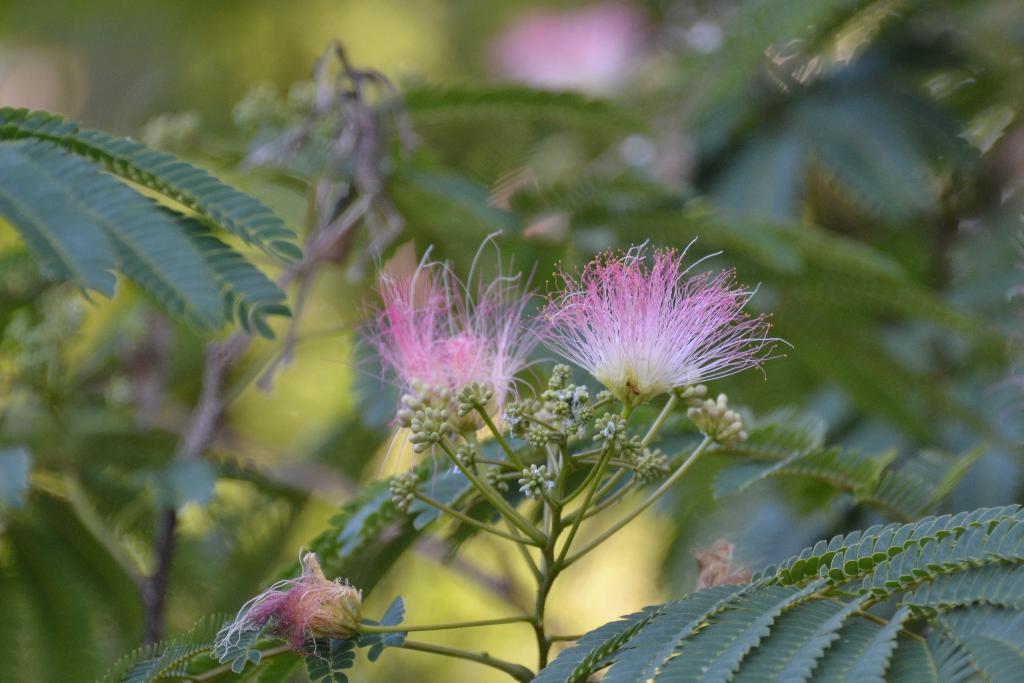Describe this image in one or two sentences. This picture shows a tree and we see few flowers to it. 